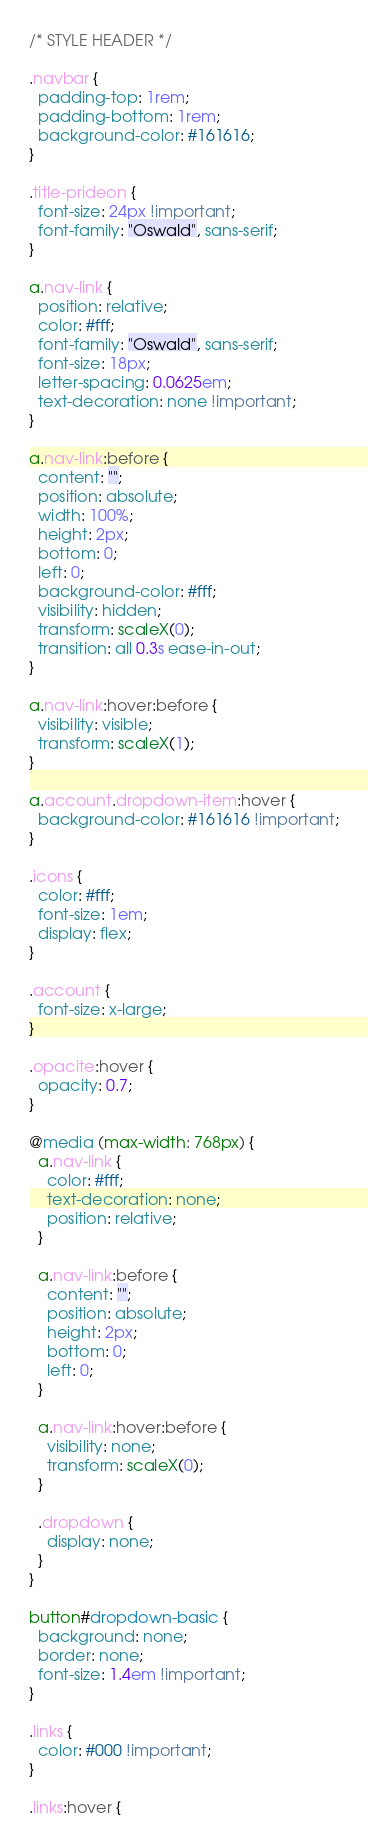Convert code to text. <code><loc_0><loc_0><loc_500><loc_500><_CSS_>/* STYLE HEADER */

.navbar {
  padding-top: 1rem;
  padding-bottom: 1rem;
  background-color: #161616;
}

.title-prideon {
  font-size: 24px !important;
  font-family: "Oswald", sans-serif;
}

a.nav-link {
  position: relative;
  color: #fff;
  font-family: "Oswald", sans-serif;
  font-size: 18px;
  letter-spacing: 0.0625em;
  text-decoration: none !important;
}

a.nav-link:before {
  content: "";
  position: absolute;
  width: 100%;
  height: 2px;
  bottom: 0;
  left: 0;
  background-color: #fff;
  visibility: hidden;
  transform: scaleX(0);
  transition: all 0.3s ease-in-out;
}

a.nav-link:hover:before {
  visibility: visible;
  transform: scaleX(1);
}

a.account.dropdown-item:hover {
  background-color: #161616 !important;
}

.icons {
  color: #fff;
  font-size: 1em;
  display: flex;
}

.account {
  font-size: x-large;
}

.opacite:hover {
  opacity: 0.7;
}

@media (max-width: 768px) {
  a.nav-link {
    color: #fff;
    text-decoration: none;
    position: relative;
  }

  a.nav-link:before {
    content: "";
    position: absolute;
    height: 2px;
    bottom: 0;
    left: 0;
  }

  a.nav-link:hover:before {
    visibility: none;
    transform: scaleX(0);
  }

  .dropdown {
    display: none;
  }
}

button#dropdown-basic {
  background: none;
  border: none;
  font-size: 1.4em !important;
}

.links {
  color: #000 !important;
}

.links:hover {</code> 